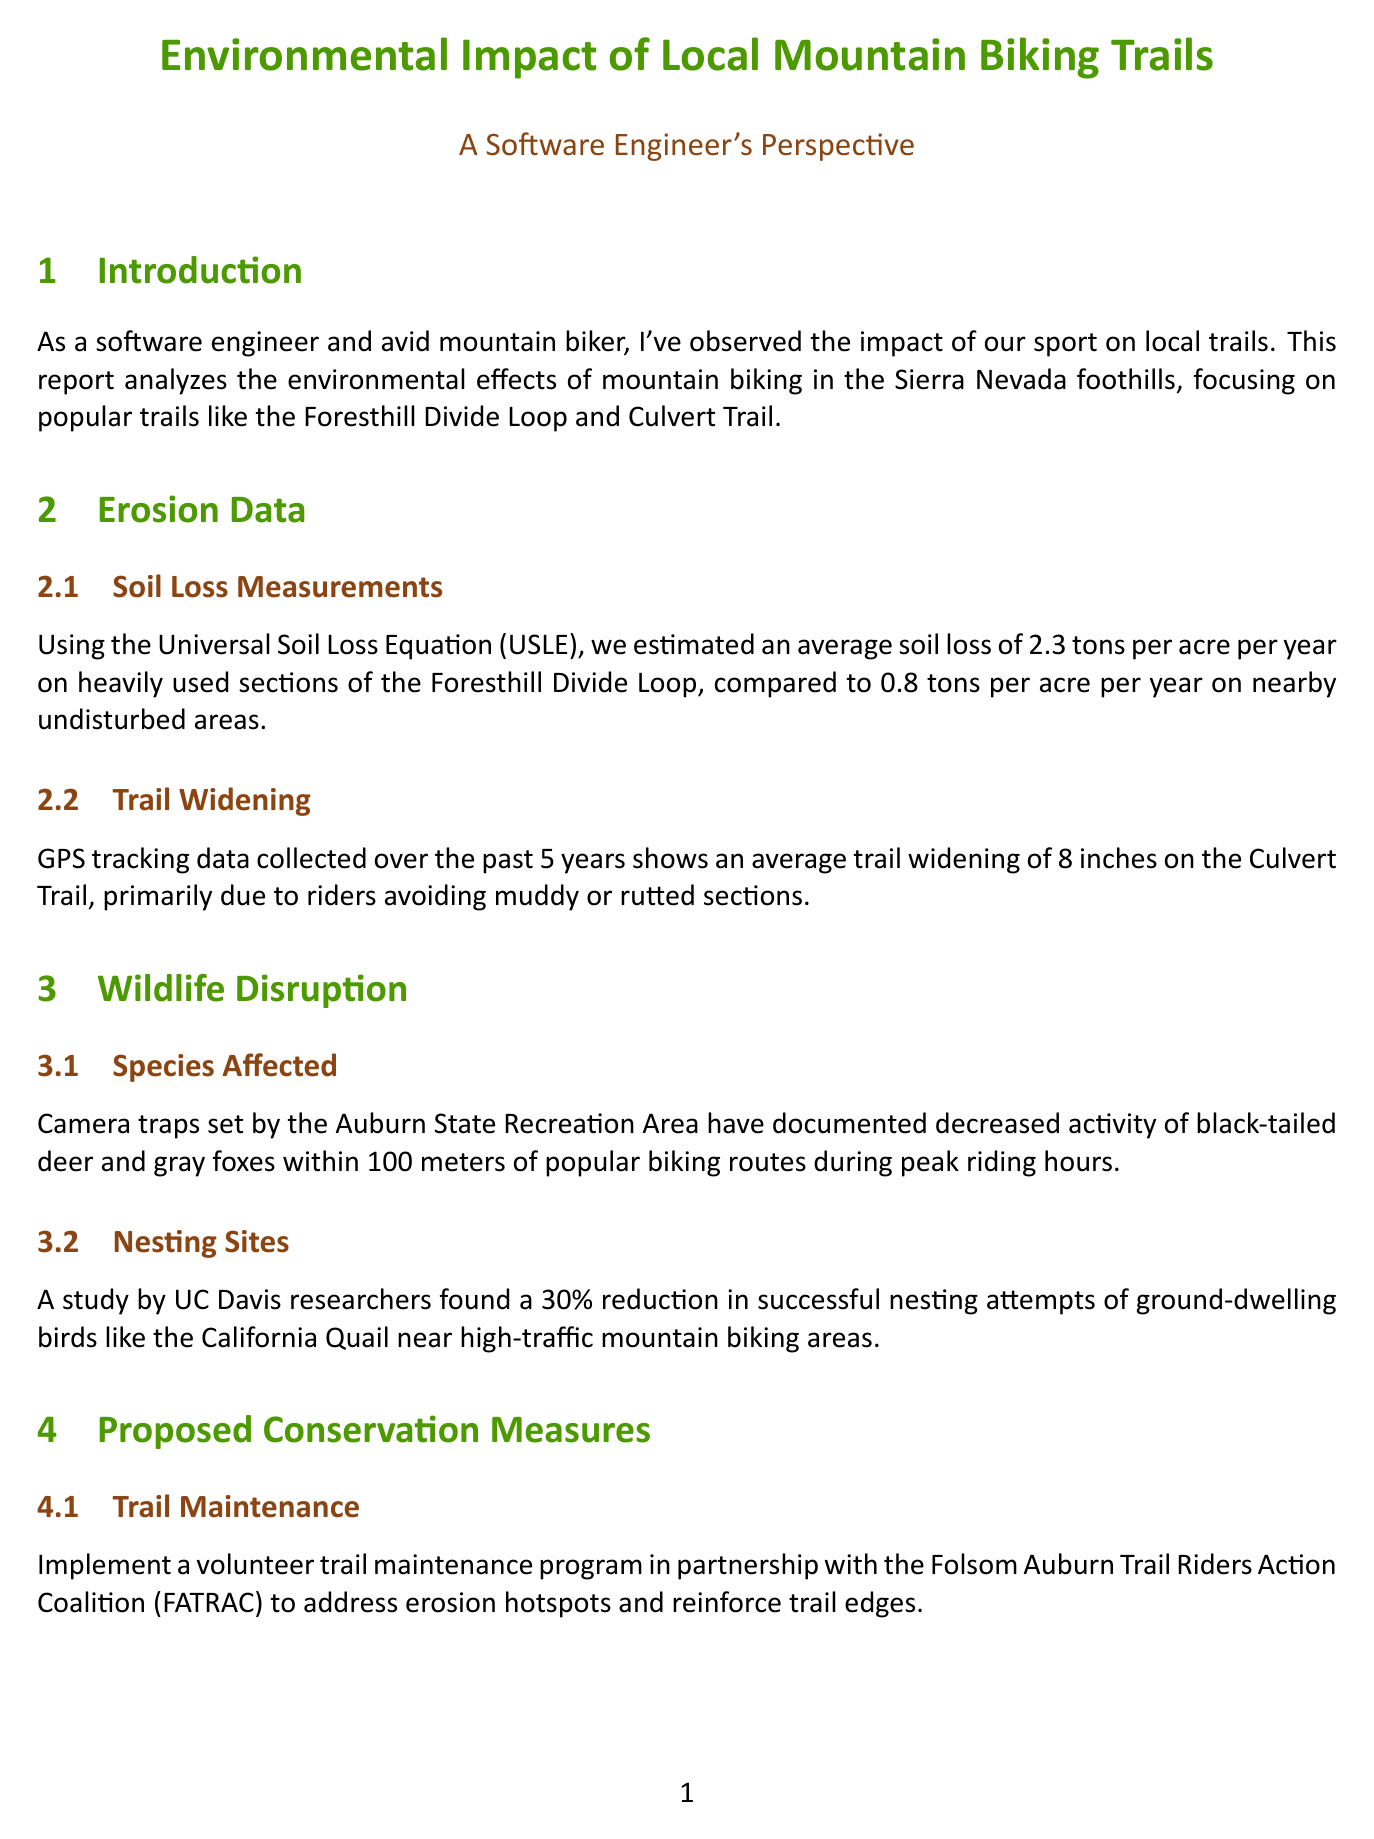What is the primary focus of the report? The report analyzes the environmental effects of mountain biking in the Sierra Nevada foothills.
Answer: environmental effects of mountain biking What is the average soil loss per acre per year on the Foresthill Divide Loop? The report states an average soil loss of 2.3 tons per acre per year on heavily used sections.
Answer: 2.3 tons By how much has the Culvert Trail widened on average? The document reports an average trail widening of 8 inches on the Culvert Trail.
Answer: 8 inches What percentage reduction in successful nesting attempts of ground-dwelling birds was found? The report mentions a 30% reduction in successful nesting attempts of ground-dwelling birds near high-traffic areas.
Answer: 30% What organization is proposed to partner for the volunteer trail maintenance program? The report proposes a partnership with the Folsom Auburn Trail Riders Action Coalition (FATRAC).
Answer: FATRAC Which species showed decreased activity near popular biking routes? The camera traps documented decreased activity of black-tailed deer and gray foxes within 100 meters of popular routes.
Answer: black-tailed deer and gray foxes What is one of the proposed conservation measures regarding seasonal closures? The document suggests establishing temporary closures of sensitive sections during the wet season from November to April.
Answer: November to April What technology does the report suggest to track rider movements? The author proposes developing a mobile app that uses GPS data to track rider movements.
Answer: mobile app 